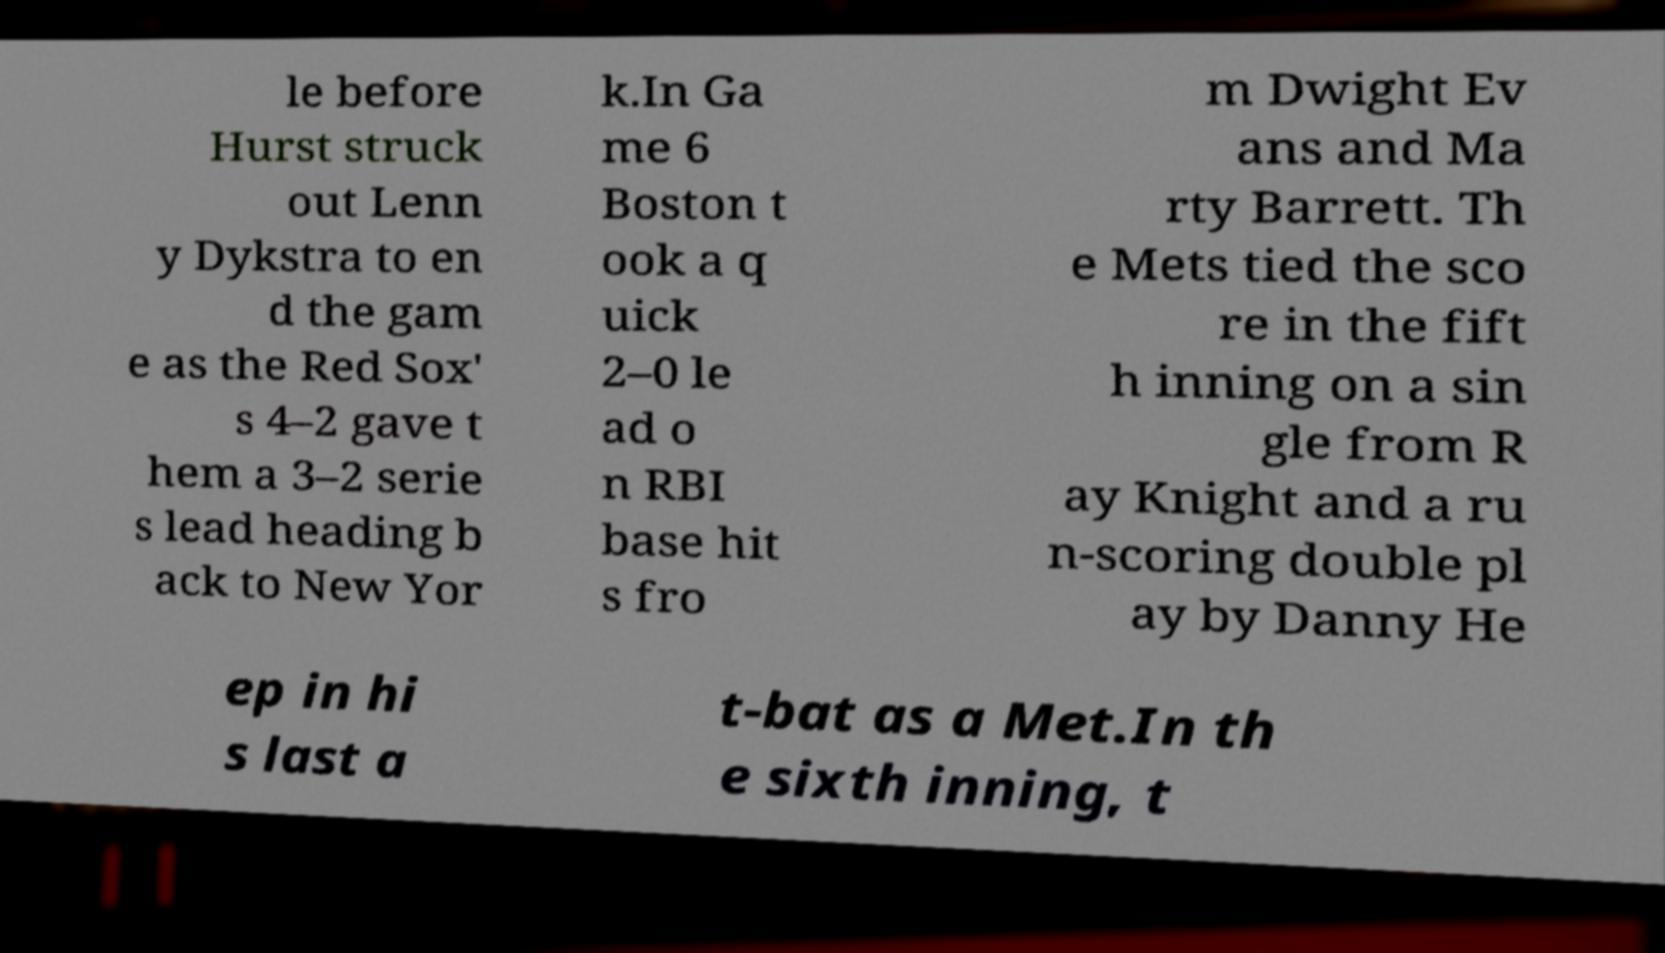Can you read and provide the text displayed in the image?This photo seems to have some interesting text. Can you extract and type it out for me? le before Hurst struck out Lenn y Dykstra to en d the gam e as the Red Sox' s 4–2 gave t hem a 3–2 serie s lead heading b ack to New Yor k.In Ga me 6 Boston t ook a q uick 2–0 le ad o n RBI base hit s fro m Dwight Ev ans and Ma rty Barrett. Th e Mets tied the sco re in the fift h inning on a sin gle from R ay Knight and a ru n-scoring double pl ay by Danny He ep in hi s last a t-bat as a Met.In th e sixth inning, t 